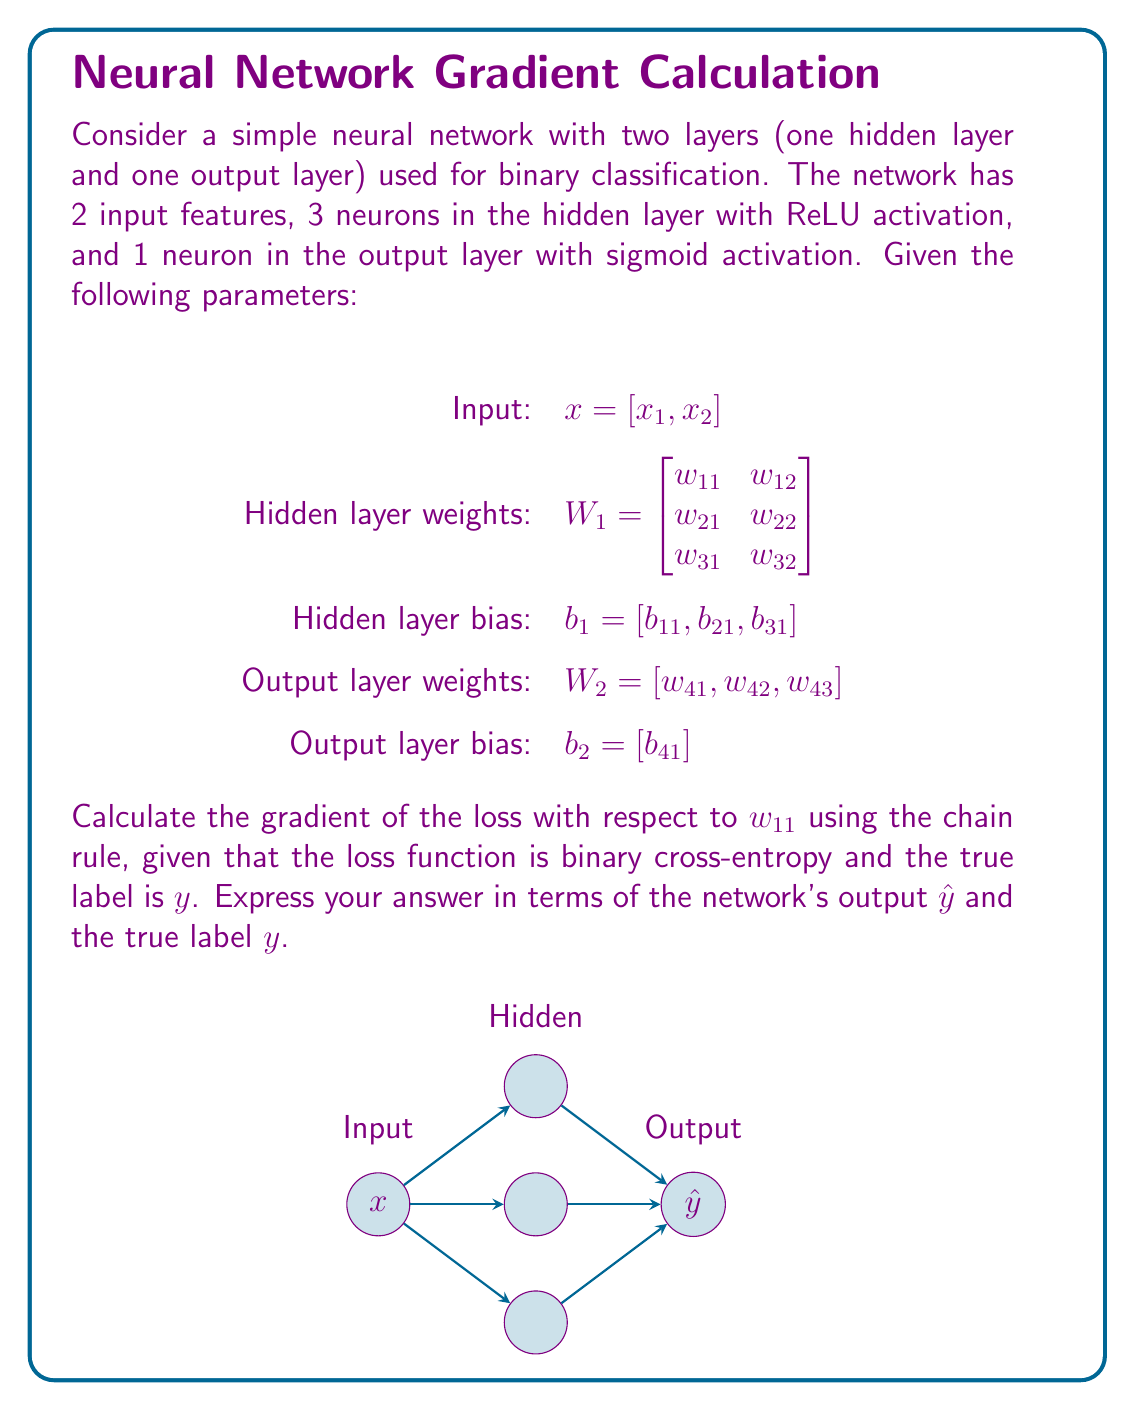What is the answer to this math problem? Let's break this down step-by-step:

1) First, we need to understand the forward pass:
   - Hidden layer: $z_1 = W_1x + b_1$, $a_1 = ReLU(z_1)$
   - Output layer: $z_2 = W_2a_1 + b_2$, $\hat{y} = \sigma(z_2)$

2) The binary cross-entropy loss is:
   $L = -[y\log(\hat{y}) + (1-y)\log(1-\hat{y})]$

3) We want to find $\frac{\partial L}{\partial w_{11}}$. Using the chain rule:

   $$\frac{\partial L}{\partial w_{11}} = \frac{\partial L}{\partial \hat{y}} \cdot \frac{\partial \hat{y}}{\partial z_2} \cdot \frac{\partial z_2}{\partial a_1} \cdot \frac{\partial a_1}{\partial z_1} \cdot \frac{\partial z_1}{\partial w_{11}}$$

4) Let's calculate each term:
   
   a) $\frac{\partial L}{\partial \hat{y}} = -\frac{y}{\hat{y}} + \frac{1-y}{1-\hat{y}}$
   
   b) $\frac{\partial \hat{y}}{\partial z_2} = \hat{y}(1-\hat{y})$ (derivative of sigmoid)
   
   c) $\frac{\partial z_2}{\partial a_1} = w_{41}$ (first element of $W_2$)
   
   d) $\frac{\partial a_1}{\partial z_1} = \begin{cases} 1 & \text{if } z_1 > 0 \\ 0 & \text{if } z_1 \leq 0 \end{cases}$ (derivative of ReLU)
   
   e) $\frac{\partial z_1}{\partial w_{11}} = x_1$

5) Combining these terms:

   $$\frac{\partial L}{\partial w_{11}} = (-\frac{y}{\hat{y}} + \frac{1-y}{1-\hat{y}}) \cdot \hat{y}(1-\hat{y}) \cdot w_{41} \cdot \mathbb{1}(z_1 > 0) \cdot x_1$$

6) Simplifying:

   $$\frac{\partial L}{\partial w_{11}} = (\hat{y} - y) \cdot w_{41} \cdot \mathbb{1}(z_1 > 0) \cdot x_1$$

Where $\mathbb{1}(z_1 > 0)$ is the indicator function, equal to 1 if $z_1 > 0$ and 0 otherwise.
Answer: $$\frac{\partial L}{\partial w_{11}} = (\hat{y} - y) \cdot w_{41} \cdot \mathbb{1}(z_1 > 0) \cdot x_1$$ 